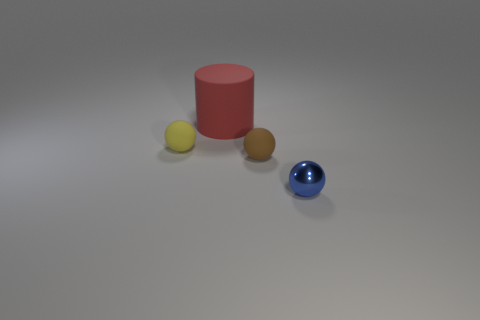Add 1 blue shiny objects. How many objects exist? 5 Subtract all balls. How many objects are left? 1 Subtract all brown spheres. Subtract all tiny shiny things. How many objects are left? 2 Add 1 blue spheres. How many blue spheres are left? 2 Add 3 green metal things. How many green metal things exist? 3 Subtract 0 purple blocks. How many objects are left? 4 